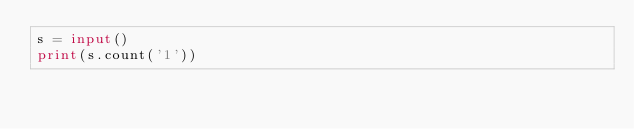<code> <loc_0><loc_0><loc_500><loc_500><_Python_>s = input()
print(s.count('1'))</code> 